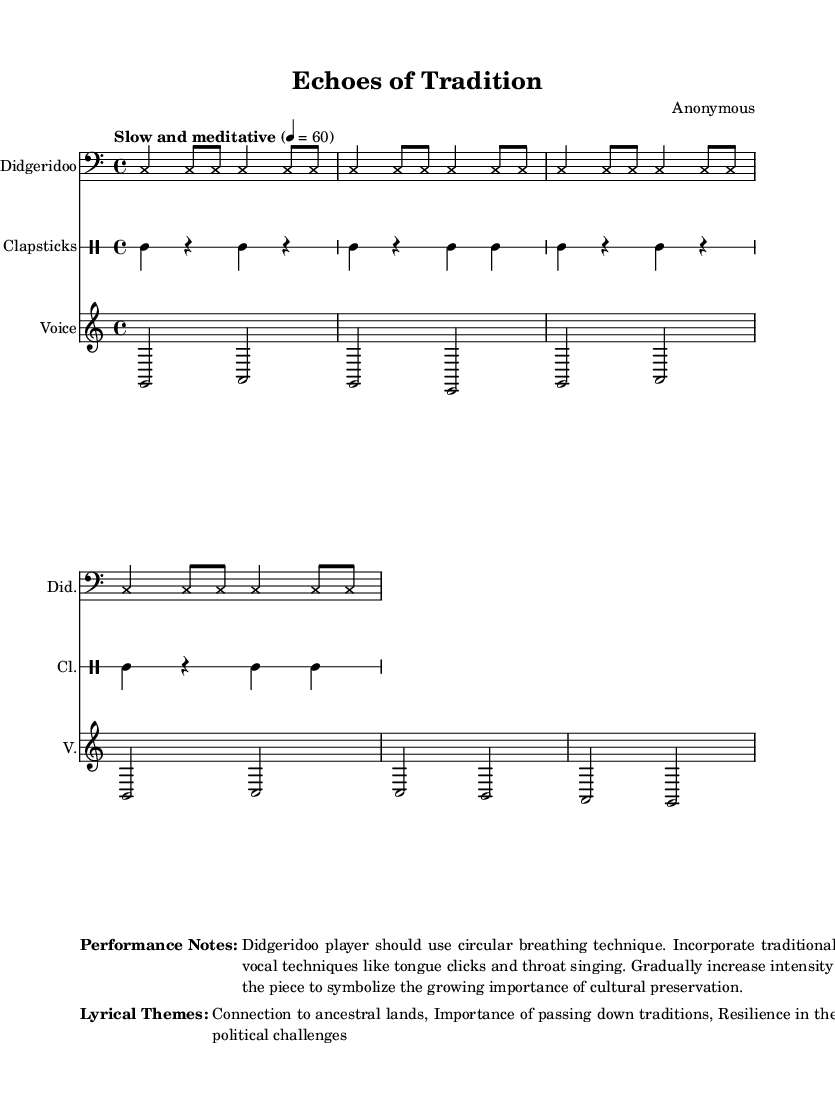What is the time signature of this music? The time signature is indicated at the beginning of the music, shown as 4/4, which means there are four beats in each measure.
Answer: 4/4 What is the tempo marking for this piece? The tempo marking appears near the top of the score and states "Slow and meditative," indicating the desired feeling and speed for the performance.
Answer: Slow and meditative How many measures are there in the didgeridoo section? By counting the measure bars in the didgeridoo notation, there are eight measures represented altogether.
Answer: Eight What instruments are featured in this piece? The instruments are specified at the beginning of each staff: Didgeridoo, Clapsticks, and Voice, which are all traditional elements in this form of music.
Answer: Didgeridoo, Clapsticks, Voice What vocal techniques are suggested in the performance notes? The performance notes mention incorporating traditional Aboriginal vocal techniques like tongue clicks and throat singing, which enhance the cultural authenticity of the music.
Answer: Tongue clicks, throat singing What is the lyrical theme regarding traditions? The lyrical themes emphasize the importance of passing down traditions, which highlights cultural preservation, and is explicitly mentioned in the notes provided.
Answer: Importance of passing down traditions How does the intensity change throughout the piece? The performance notes indicate that the intensity should gradually increase throughout the piece, symbolizing the growing importance of cultural preservation, suggesting a dynamic progression.
Answer: Gradually increase intensity 